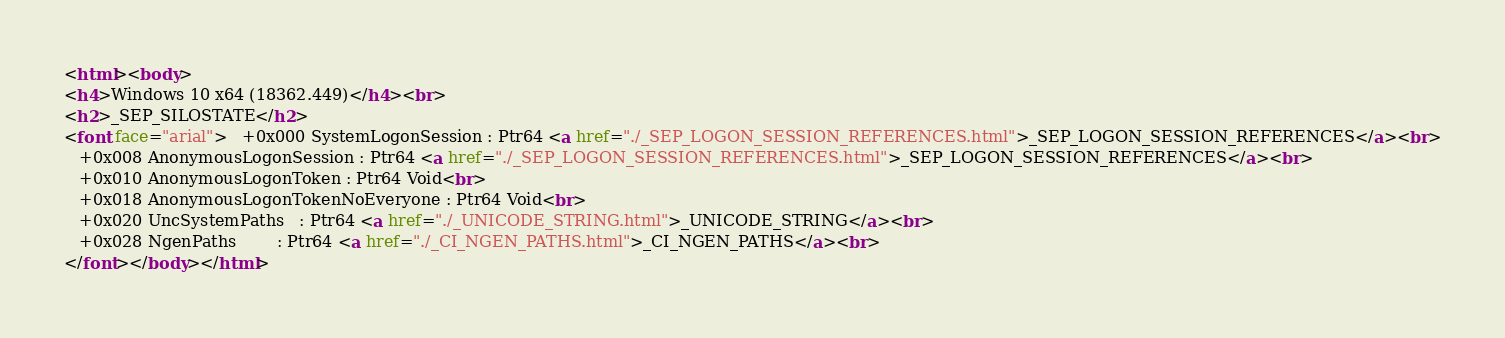<code> <loc_0><loc_0><loc_500><loc_500><_HTML_><html><body>
<h4>Windows 10 x64 (18362.449)</h4><br>
<h2>_SEP_SILOSTATE</h2>
<font face="arial">   +0x000 SystemLogonSession : Ptr64 <a href="./_SEP_LOGON_SESSION_REFERENCES.html">_SEP_LOGON_SESSION_REFERENCES</a><br>
   +0x008 AnonymousLogonSession : Ptr64 <a href="./_SEP_LOGON_SESSION_REFERENCES.html">_SEP_LOGON_SESSION_REFERENCES</a><br>
   +0x010 AnonymousLogonToken : Ptr64 Void<br>
   +0x018 AnonymousLogonTokenNoEveryone : Ptr64 Void<br>
   +0x020 UncSystemPaths   : Ptr64 <a href="./_UNICODE_STRING.html">_UNICODE_STRING</a><br>
   +0x028 NgenPaths        : Ptr64 <a href="./_CI_NGEN_PATHS.html">_CI_NGEN_PATHS</a><br>
</font></body></html></code> 